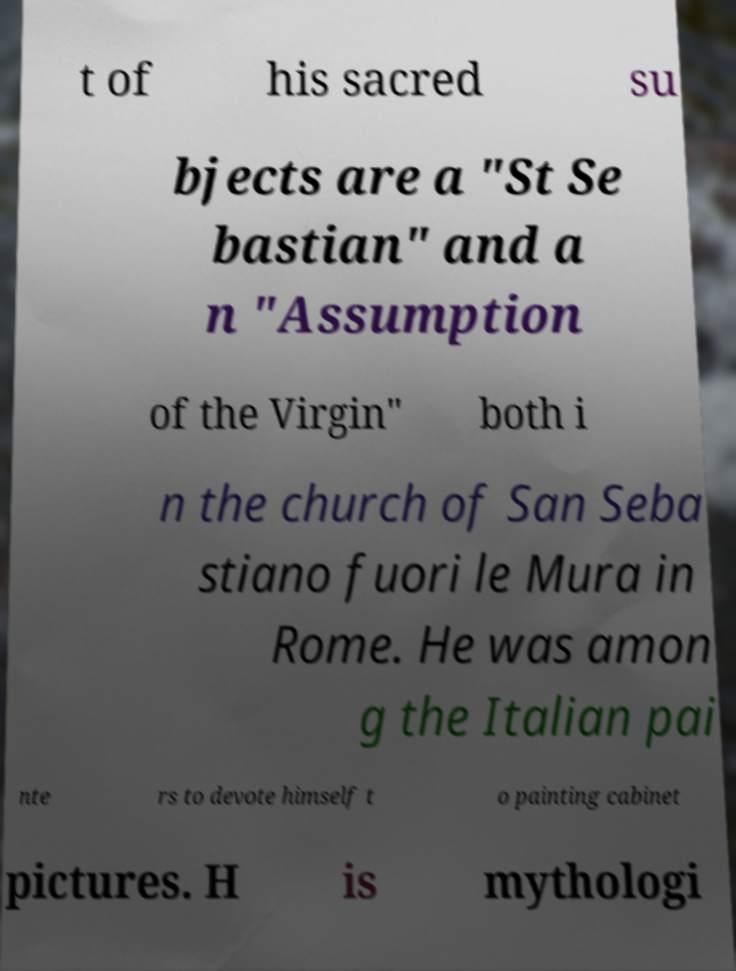Could you extract and type out the text from this image? t of his sacred su bjects are a "St Se bastian" and a n "Assumption of the Virgin" both i n the church of San Seba stiano fuori le Mura in Rome. He was amon g the Italian pai nte rs to devote himself t o painting cabinet pictures. H is mythologi 